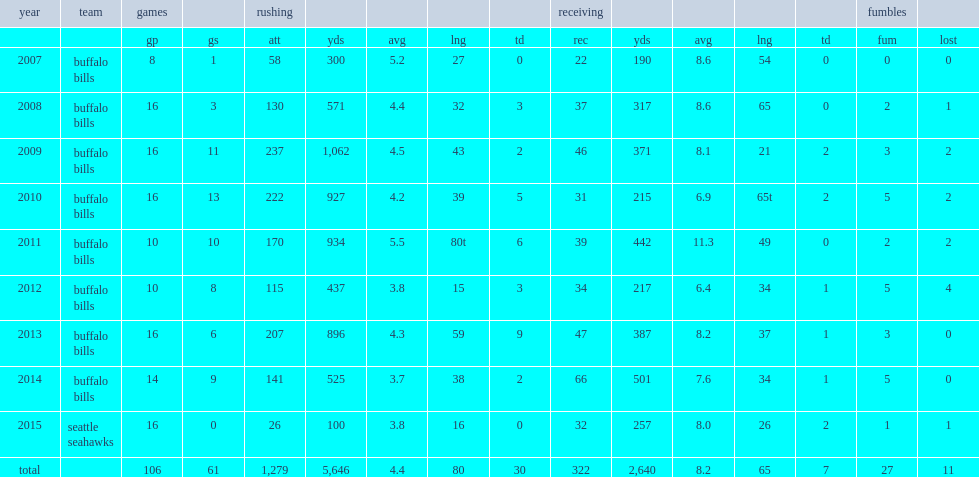Can you give me this table as a dict? {'header': ['year', 'team', 'games', '', 'rushing', '', '', '', '', 'receiving', '', '', '', '', 'fumbles', ''], 'rows': [['', '', 'gp', 'gs', 'att', 'yds', 'avg', 'lng', 'td', 'rec', 'yds', 'avg', 'lng', 'td', 'fum', 'lost'], ['2007', 'buffalo bills', '8', '1', '58', '300', '5.2', '27', '0', '22', '190', '8.6', '54', '0', '0', '0'], ['2008', 'buffalo bills', '16', '3', '130', '571', '4.4', '32', '3', '37', '317', '8.6', '65', '0', '2', '1'], ['2009', 'buffalo bills', '16', '11', '237', '1,062', '4.5', '43', '2', '46', '371', '8.1', '21', '2', '3', '2'], ['2010', 'buffalo bills', '16', '13', '222', '927', '4.2', '39', '5', '31', '215', '6.9', '65t', '2', '5', '2'], ['2011', 'buffalo bills', '10', '10', '170', '934', '5.5', '80t', '6', '39', '442', '11.3', '49', '0', '2', '2'], ['2012', 'buffalo bills', '10', '8', '115', '437', '3.8', '15', '3', '34', '217', '6.4', '34', '1', '5', '4'], ['2013', 'buffalo bills', '16', '6', '207', '896', '4.3', '59', '9', '47', '387', '8.2', '37', '1', '3', '0'], ['2014', 'buffalo bills', '14', '9', '141', '525', '3.7', '38', '2', '66', '501', '7.6', '34', '1', '5', '0'], ['2015', 'seattle seahawks', '16', '0', '26', '100', '3.8', '16', '0', '32', '257', '8.0', '26', '2', '1', '1'], ['total', '', '106', '61', '1,279', '5,646', '4.4', '80', '30', '322', '2,640', '8.2', '65', '7', '27', '11']]} How many rushing yards did jackson get in 2007? 300.0. 